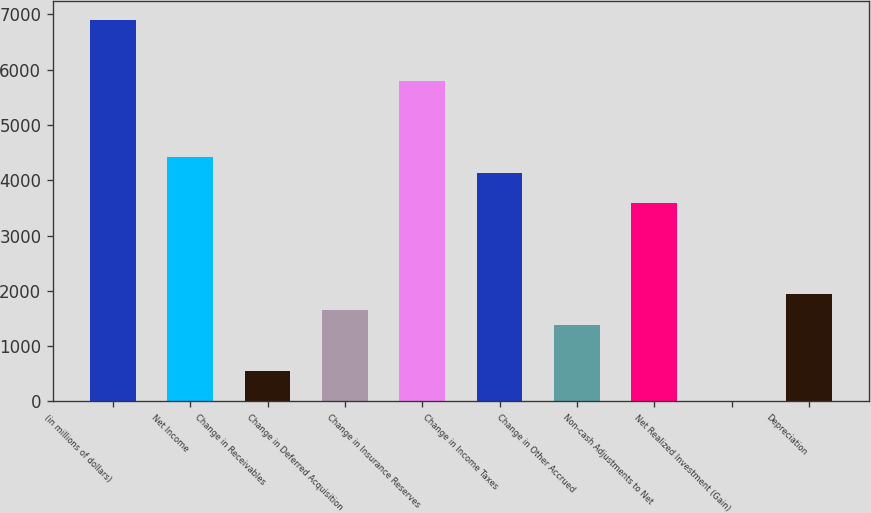<chart> <loc_0><loc_0><loc_500><loc_500><bar_chart><fcel>(in millions of dollars)<fcel>Net Income<fcel>Change in Receivables<fcel>Change in Deferred Acquisition<fcel>Change in Insurance Reserves<fcel>Change in Income Taxes<fcel>Change in Other Accrued<fcel>Non-cash Adjustments to Net<fcel>Net Realized Investment (Gain)<fcel>Depreciation<nl><fcel>6892.9<fcel>4413.22<fcel>555.94<fcel>1658.02<fcel>5790.82<fcel>4137.7<fcel>1382.5<fcel>3586.66<fcel>4.9<fcel>1933.54<nl></chart> 